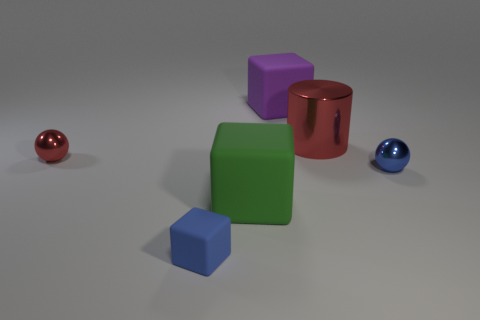Subtract all purple blocks. How many blocks are left? 2 Subtract 1 blocks. How many blocks are left? 2 Add 2 shiny spheres. How many objects exist? 8 Subtract all cylinders. How many objects are left? 5 Add 4 big objects. How many big objects exist? 7 Subtract 1 green blocks. How many objects are left? 5 Subtract all cubes. Subtract all small balls. How many objects are left? 1 Add 3 red cylinders. How many red cylinders are left? 4 